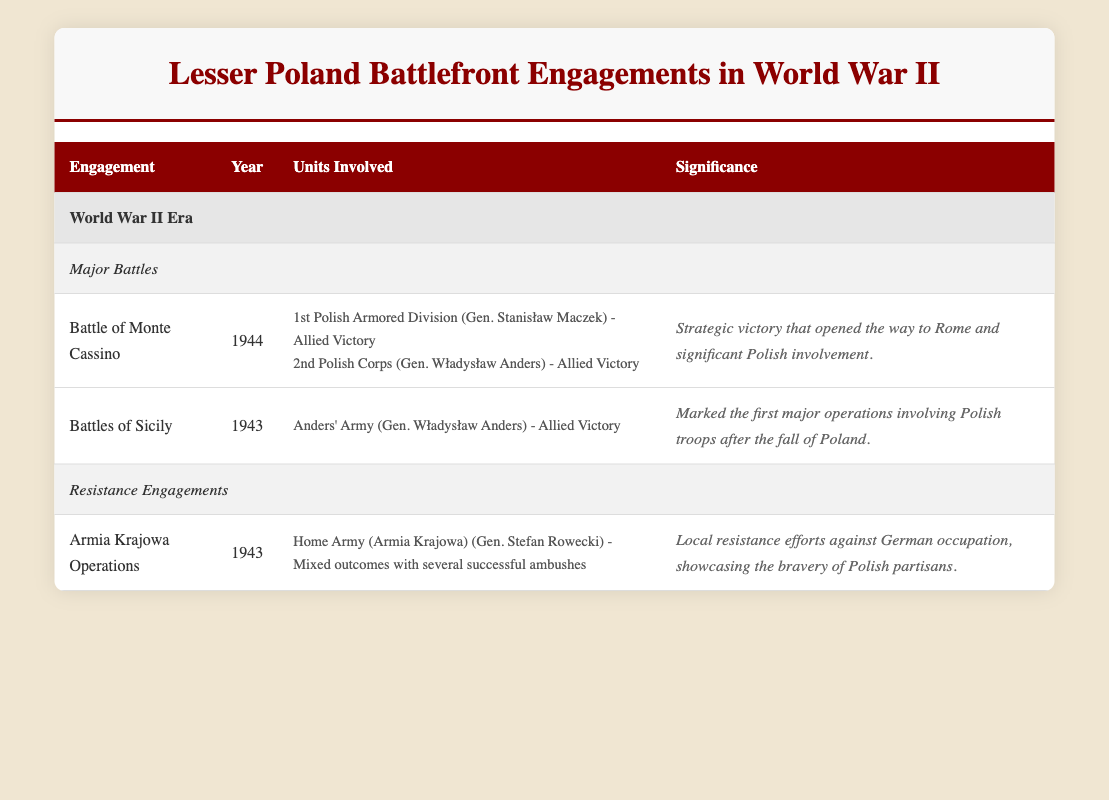What was the outcome of the Battle of Monte Cassino? The table states that the outcome of the Battle of Monte Cassino is "Allied Victory."
Answer: Allied Victory Who commanded the Home Army during the Armia Krajowa Operations? According to the table, the leader of the Home Army (Armia Krajowa) was Gen. Stefan Rowecki.
Answer: Gen. Stefan Rowecki In which year did the Battles of Sicily occur? The table shows that the Battles of Sicily took place in the year 1943.
Answer: 1943 Were there any Polish units involved in the Battle of Monte Cassino? Yes, the table lists two units: the 1st Polish Armored Division and the 2nd Polish Corps, both involved in the battle.
Answer: Yes How many major battles are recorded in the table? The table lists two major battles: the Battle of Monte Cassino and the Battles of Sicily, hence the total is 2.
Answer: 2 What is the significance of the Battles of Sicily? The table indicates that the Battles of Sicily marked the first major operations involving Polish troops after the fall of Poland.
Answer: First major operations after fall of Poland Which unit had mixed outcomes in their engagements? The Home Army (Armia Krajowa) during the Armia Krajowa Operations is noted for having "mixed outcomes with several successful ambushes."
Answer: Home Army (Armia Krajowa) Which battle opened the way to Rome? The Battle of Monte Cassino is highlighted in the table as having strategic victory that opened the way to Rome.
Answer: Battle of Monte Cassino Did Gen. Władysław Anders command different units in both battles listed? Yes, Gen. Władysław Anders commanded the 2nd Polish Corps in the Battle of Monte Cassino and Anders' Army in the Battles of Sicily, indicating different units.
Answer: Yes How does the significance of the two major battles compare? The Battle of Monte Cassino's significance is described as a strategic victory that opened the way to Rome, while the significance of the Battles of Sicily focused on marking a critical point for Polish forces post-occupation, showing that the former had a greater strategic impact.
Answer: Monte Cassino had greater strategic impact 